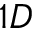Convert formula to latex. <formula><loc_0><loc_0><loc_500><loc_500>1 D</formula> 